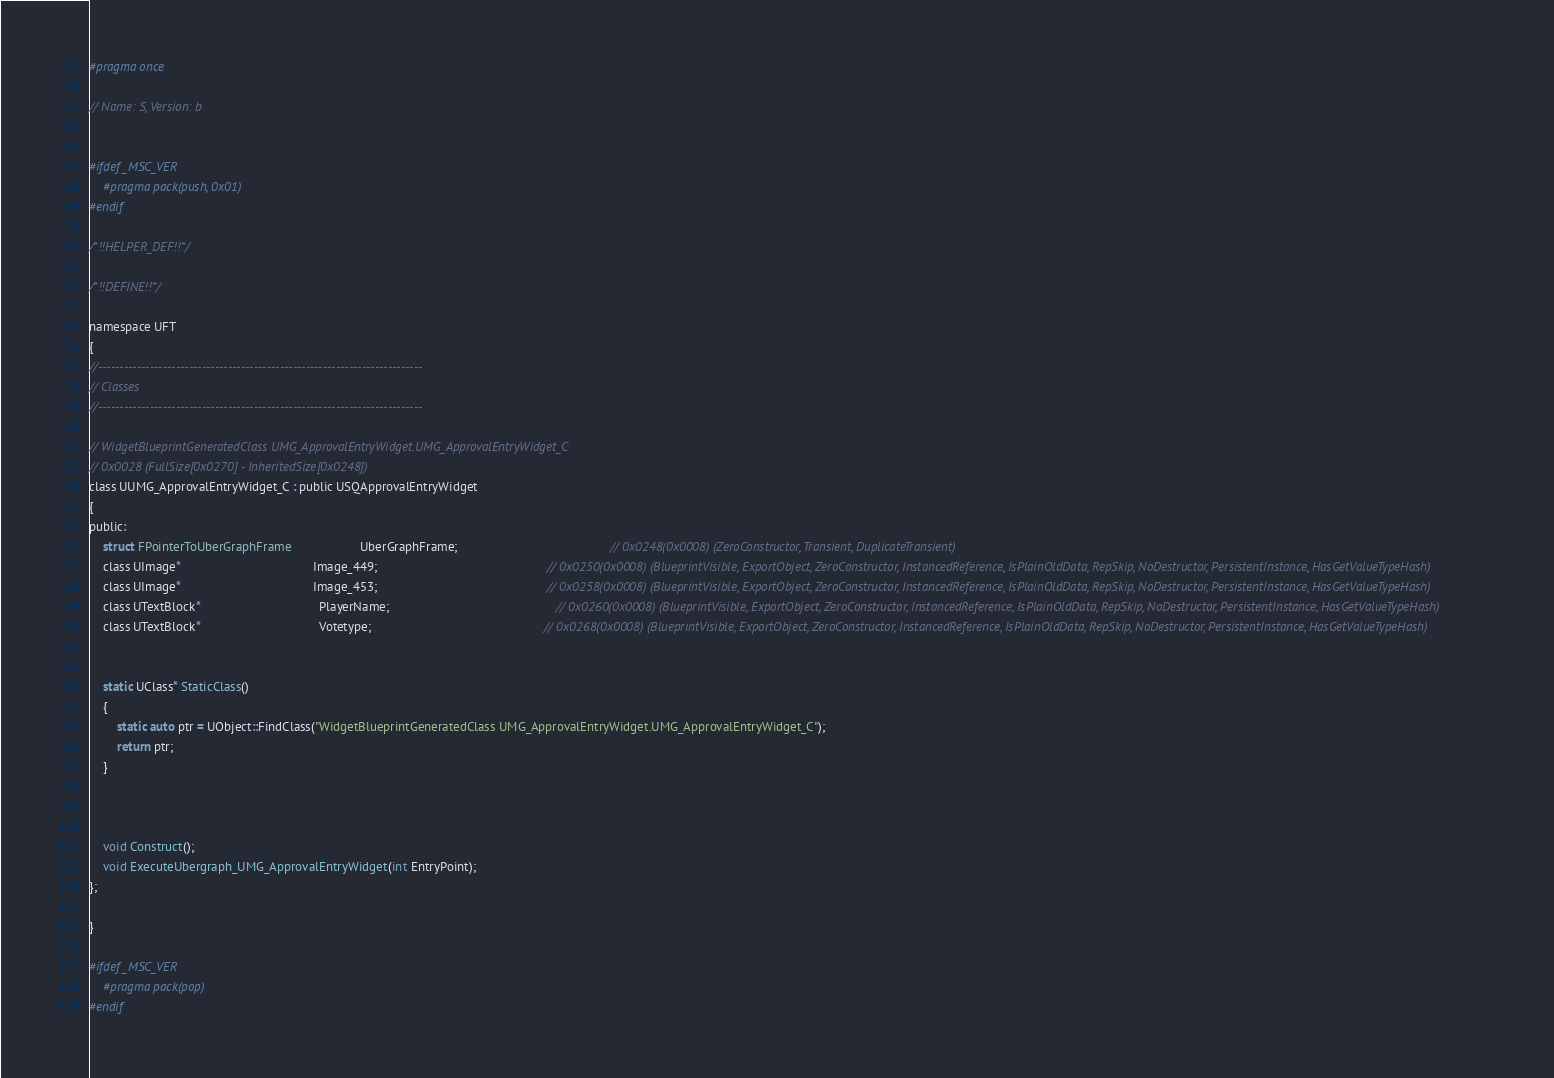Convert code to text. <code><loc_0><loc_0><loc_500><loc_500><_C_>#pragma once

// Name: S, Version: b


#ifdef _MSC_VER
	#pragma pack(push, 0x01)
#endif

/*!!HELPER_DEF!!*/

/*!!DEFINE!!*/

namespace UFT
{
//---------------------------------------------------------------------------
// Classes
//---------------------------------------------------------------------------

// WidgetBlueprintGeneratedClass UMG_ApprovalEntryWidget.UMG_ApprovalEntryWidget_C
// 0x0028 (FullSize[0x0270] - InheritedSize[0x0248])
class UUMG_ApprovalEntryWidget_C : public USQApprovalEntryWidget
{
public:
	struct FPointerToUberGraphFrame                    UberGraphFrame;                                            // 0x0248(0x0008) (ZeroConstructor, Transient, DuplicateTransient)
	class UImage*                                      Image_449;                                                 // 0x0250(0x0008) (BlueprintVisible, ExportObject, ZeroConstructor, InstancedReference, IsPlainOldData, RepSkip, NoDestructor, PersistentInstance, HasGetValueTypeHash)
	class UImage*                                      Image_453;                                                 // 0x0258(0x0008) (BlueprintVisible, ExportObject, ZeroConstructor, InstancedReference, IsPlainOldData, RepSkip, NoDestructor, PersistentInstance, HasGetValueTypeHash)
	class UTextBlock*                                  PlayerName;                                                // 0x0260(0x0008) (BlueprintVisible, ExportObject, ZeroConstructor, InstancedReference, IsPlainOldData, RepSkip, NoDestructor, PersistentInstance, HasGetValueTypeHash)
	class UTextBlock*                                  Votetype;                                                  // 0x0268(0x0008) (BlueprintVisible, ExportObject, ZeroConstructor, InstancedReference, IsPlainOldData, RepSkip, NoDestructor, PersistentInstance, HasGetValueTypeHash)


	static UClass* StaticClass()
	{
		static auto ptr = UObject::FindClass("WidgetBlueprintGeneratedClass UMG_ApprovalEntryWidget.UMG_ApprovalEntryWidget_C");
		return ptr;
	}



	void Construct();
	void ExecuteUbergraph_UMG_ApprovalEntryWidget(int EntryPoint);
};

}

#ifdef _MSC_VER
	#pragma pack(pop)
#endif
</code> 